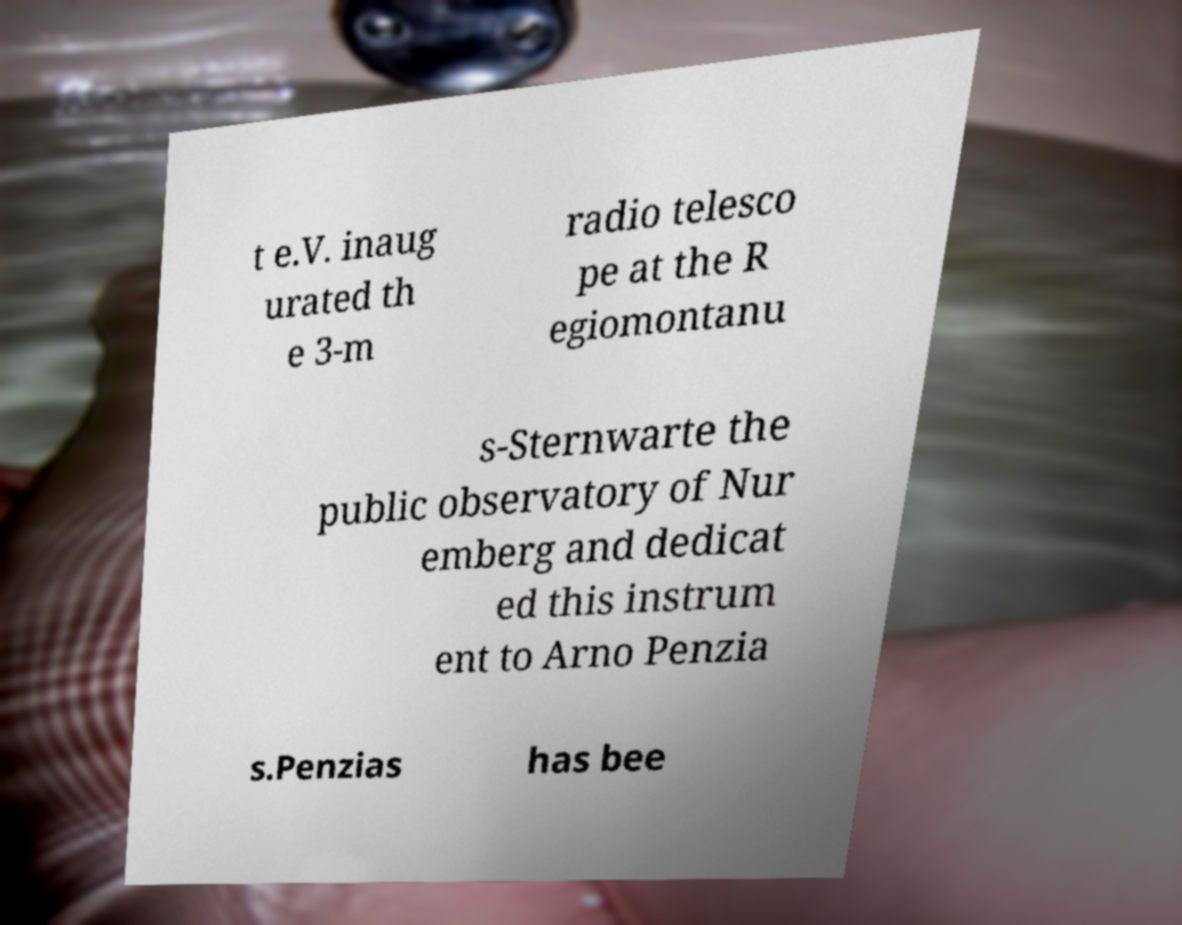Could you assist in decoding the text presented in this image and type it out clearly? t e.V. inaug urated th e 3-m radio telesco pe at the R egiomontanu s-Sternwarte the public observatory of Nur emberg and dedicat ed this instrum ent to Arno Penzia s.Penzias has bee 